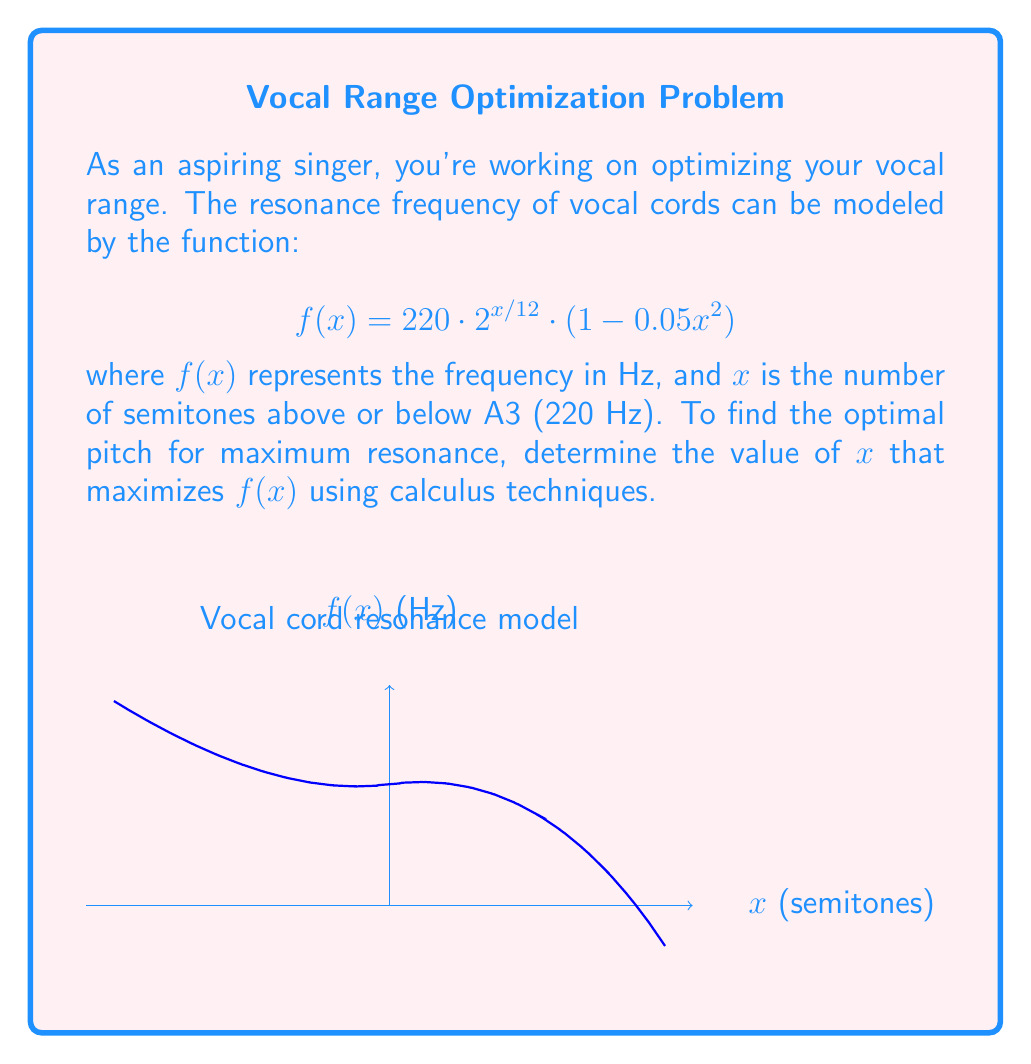Help me with this question. To find the maximum of $f(x)$, we need to follow these steps:

1) First, let's find the derivative of $f(x)$:

   $$f(x) = 220 \cdot 2^{x/12} \cdot (1 - 0.05x^2)$$
   
   Using the product rule and chain rule:
   
   $$f'(x) = 220 \cdot 2^{x/12} \cdot \frac{\ln(2)}{12} \cdot (1 - 0.05x^2) + 220 \cdot 2^{x/12} \cdot (-0.1x)$$

2) Set the derivative equal to zero to find critical points:

   $$220 \cdot 2^{x/12} \cdot [\frac{\ln(2)}{12} \cdot (1 - 0.05x^2) - 0.1x] = 0$$

3) Factor out the common term:

   $$220 \cdot 2^{x/12} \cdot [\frac{\ln(2)}{12} - \frac{\ln(2)}{240}x^2 - 0.1x] = 0$$

4) Since $220 \cdot 2^{x/12}$ is always positive, we can focus on solving:

   $$\frac{\ln(2)}{12} - \frac{\ln(2)}{240}x^2 - 0.1x = 0$$

5) This is a quadratic equation. We can solve it using the quadratic formula:

   $$x = \frac{-b \pm \sqrt{b^2 - 4ac}}{2a}$$

   Where $a = -\frac{\ln(2)}{240}$, $b = -0.1$, and $c = \frac{\ln(2)}{12}$

6) Solving this equation gives us two solutions:

   $x \approx 2.8358$ and $x \approx -7.8358$

7) To determine which solution gives the maximum, we can check the second derivative or observe that the negative solution would result in a very low frequency, which is not practical for singing.

Therefore, the maximum resonance occurs at approximately 2.8358 semitones above A3.
Answer: $x \approx 2.8358$ semitones above A3 